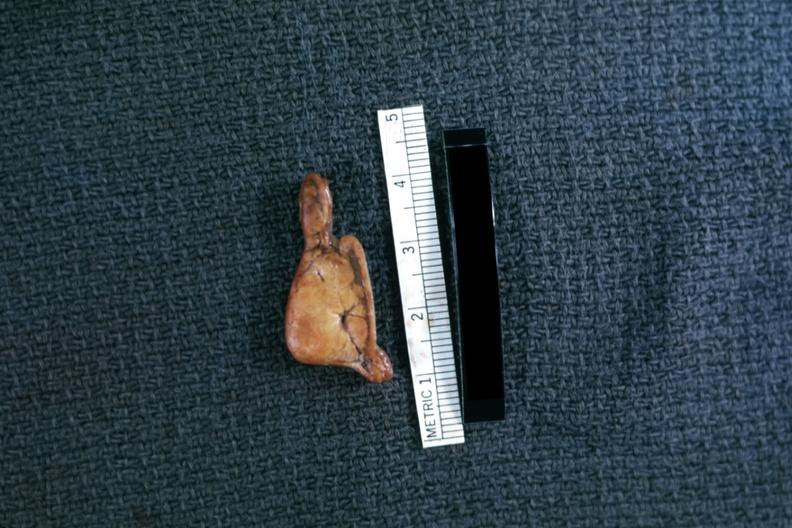s beckwith-wiedemann syndrome present?
Answer the question using a single word or phrase. No 